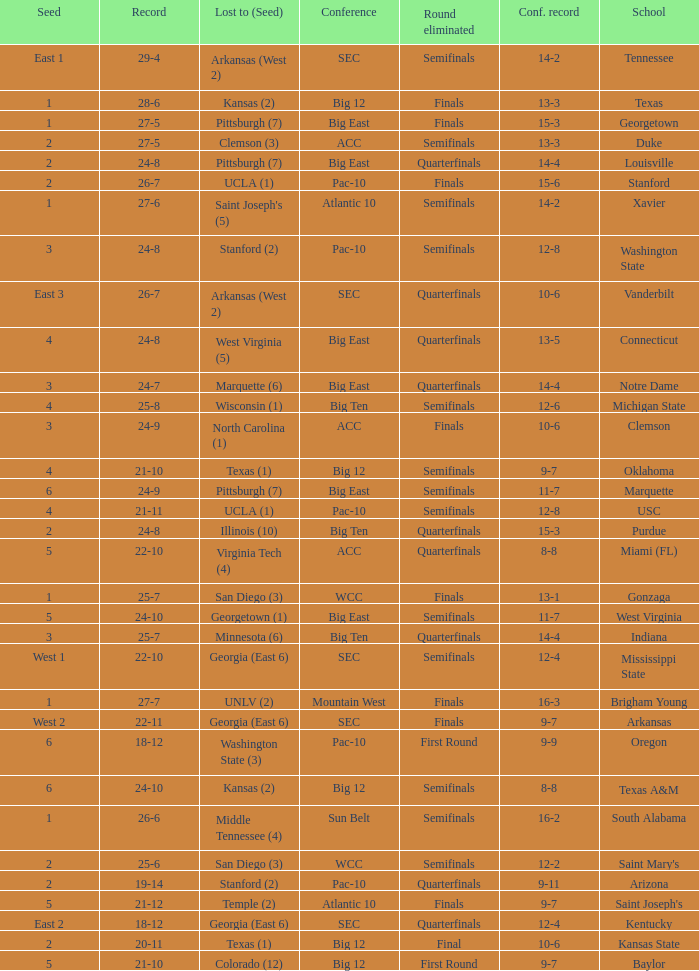Name the round eliminated where conference record is 12-6 Semifinals. 